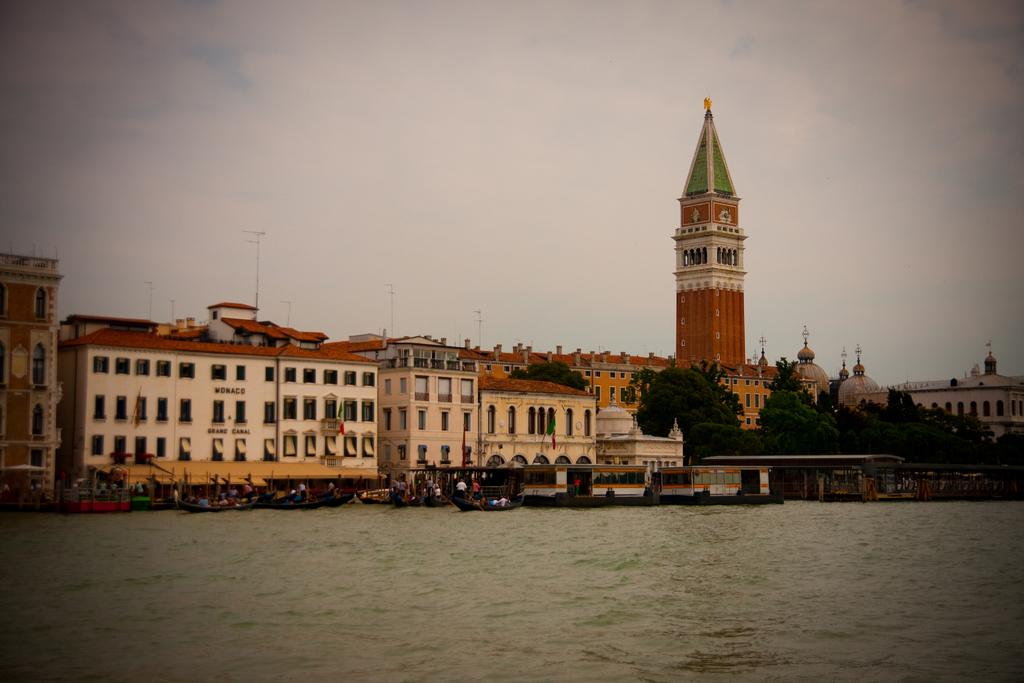What is on the water in the image? There are boats on the water in the image. What else can be seen in the image besides the boats? There are groups of people, buildings, trees, and a clock tower in the image. Can you describe the sky in the image? The sky is visible in the background of the image. What type of ink is being used by the mother in the image? There is no mother or ink present in the image. How does the transport system function in the image? There is no specific transport system mentioned in the image, as it only shows boats on the water. 